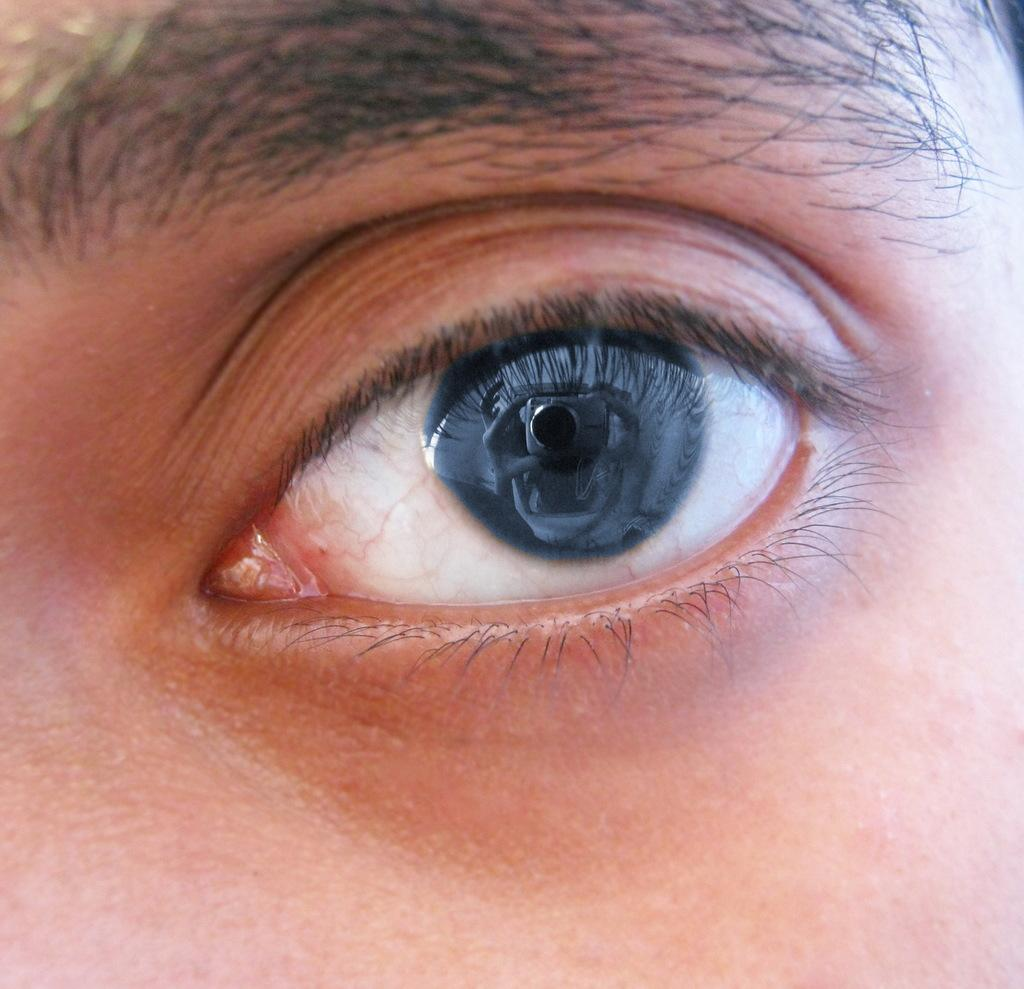What is the main subject in the center of the image? There is an eye in the center of the image. What action is the eye performing in the image? The eye is not performing any action in the image, as it is a static image. Can you tell me how the eye is pulling something in the image? The eye is not pulling anything in the image, as it is a static image. 